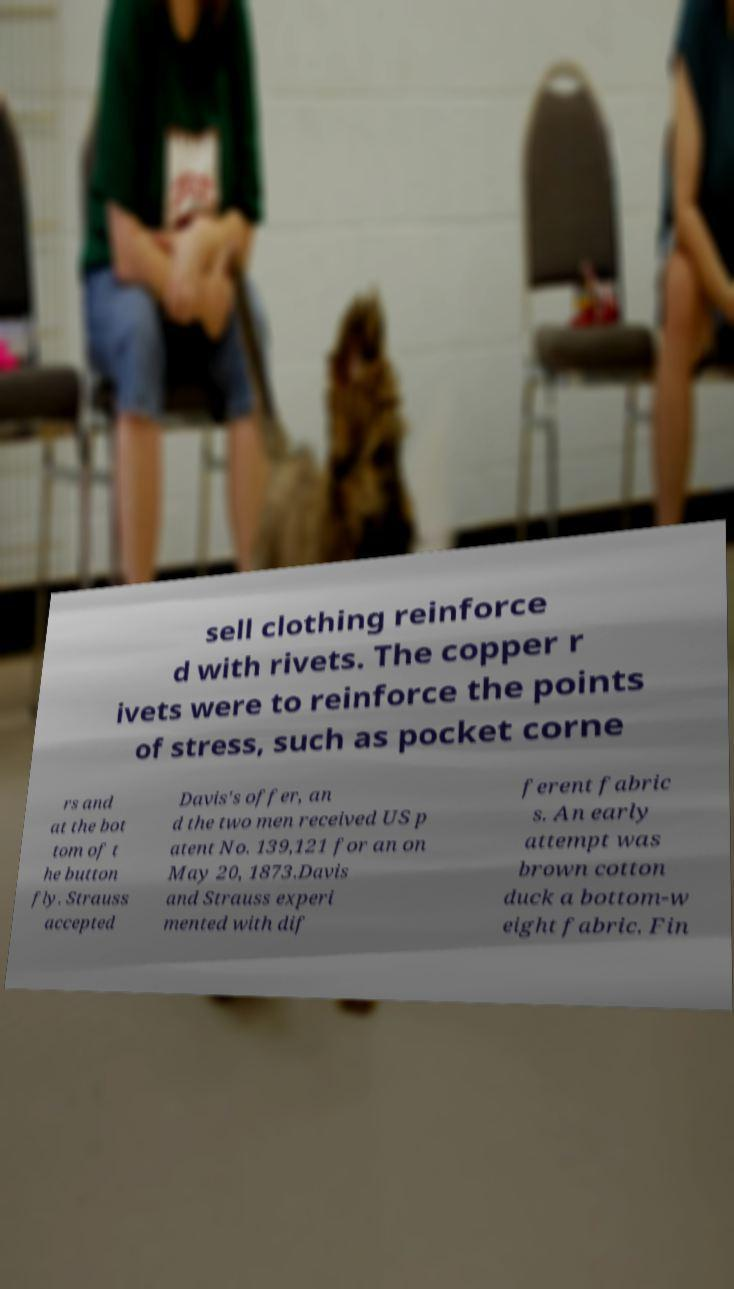What messages or text are displayed in this image? I need them in a readable, typed format. sell clothing reinforce d with rivets. The copper r ivets were to reinforce the points of stress, such as pocket corne rs and at the bot tom of t he button fly. Strauss accepted Davis's offer, an d the two men received US p atent No. 139,121 for an on May 20, 1873.Davis and Strauss experi mented with dif ferent fabric s. An early attempt was brown cotton duck a bottom-w eight fabric. Fin 